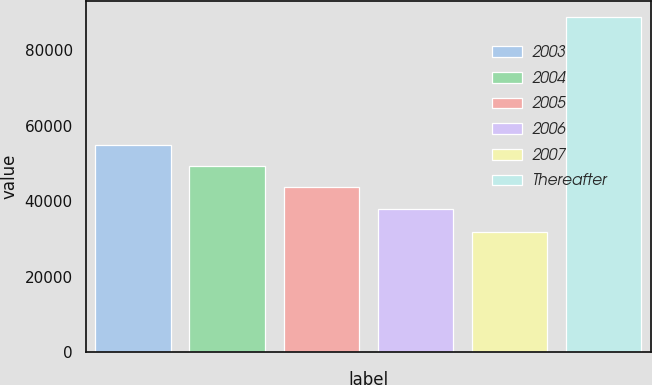Convert chart to OTSL. <chart><loc_0><loc_0><loc_500><loc_500><bar_chart><fcel>2003<fcel>2004<fcel>2005<fcel>2006<fcel>2007<fcel>Thereafter<nl><fcel>54955.9<fcel>49280.6<fcel>43605.3<fcel>37930<fcel>31902<fcel>88655<nl></chart> 